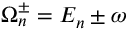<formula> <loc_0><loc_0><loc_500><loc_500>\Omega _ { n } ^ { \pm } = { E } _ { n } \pm \omega</formula> 